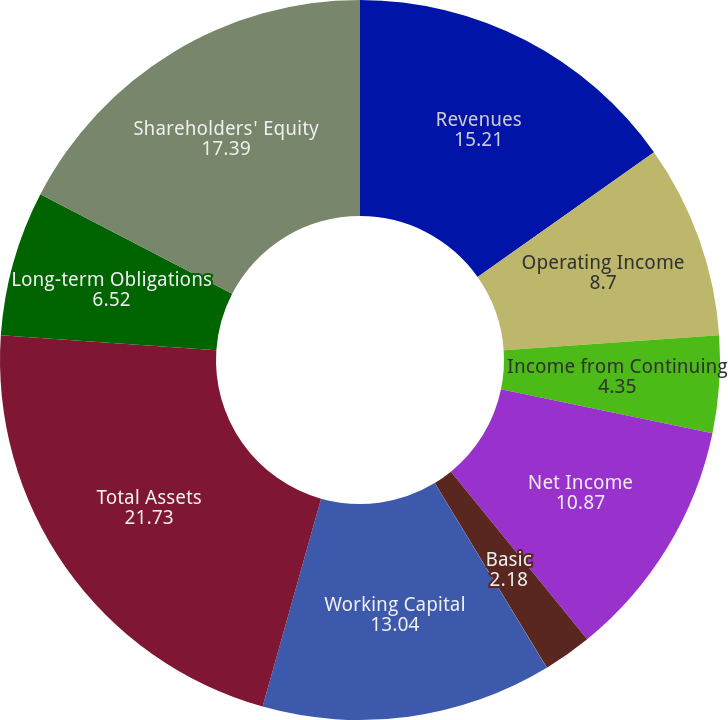Convert chart to OTSL. <chart><loc_0><loc_0><loc_500><loc_500><pie_chart><fcel>Revenues<fcel>Operating Income<fcel>Income from Continuing<fcel>Net Income<fcel>Basic<fcel>Diluted<fcel>Working Capital<fcel>Total Assets<fcel>Long-term Obligations<fcel>Shareholders' Equity<nl><fcel>15.21%<fcel>8.7%<fcel>4.35%<fcel>10.87%<fcel>2.18%<fcel>0.01%<fcel>13.04%<fcel>21.73%<fcel>6.52%<fcel>17.39%<nl></chart> 